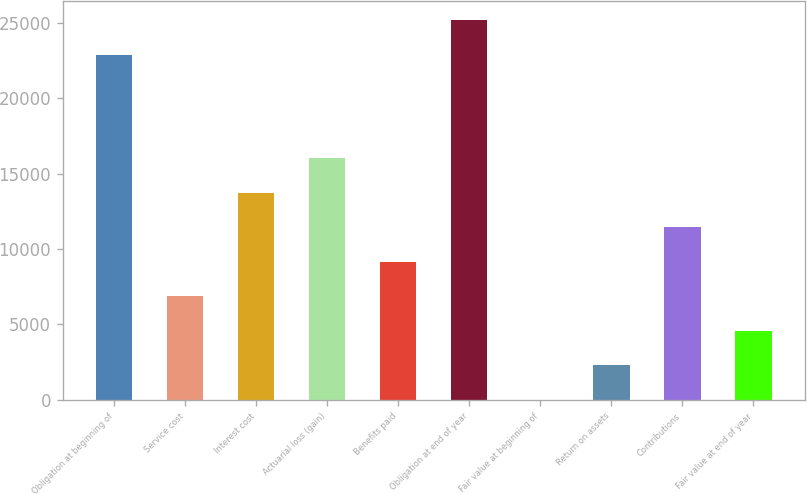Convert chart to OTSL. <chart><loc_0><loc_0><loc_500><loc_500><bar_chart><fcel>Obligation at beginning of<fcel>Service cost<fcel>Interest cost<fcel>Actuarial loss (gain)<fcel>Benefits paid<fcel>Obligation at end of year<fcel>Fair value at beginning of<fcel>Return on assets<fcel>Contributions<fcel>Fair value at end of year<nl><fcel>22895<fcel>6869.45<fcel>13737.5<fcel>16026.9<fcel>9158.81<fcel>25184.3<fcel>1.37<fcel>2290.73<fcel>11448.2<fcel>4580.09<nl></chart> 